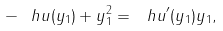<formula> <loc_0><loc_0><loc_500><loc_500>- \ h u ( y _ { 1 } ) + y _ { 1 } ^ { 2 } = { \ h u } ^ { \prime } ( y _ { 1 } ) y _ { 1 } ,</formula> 